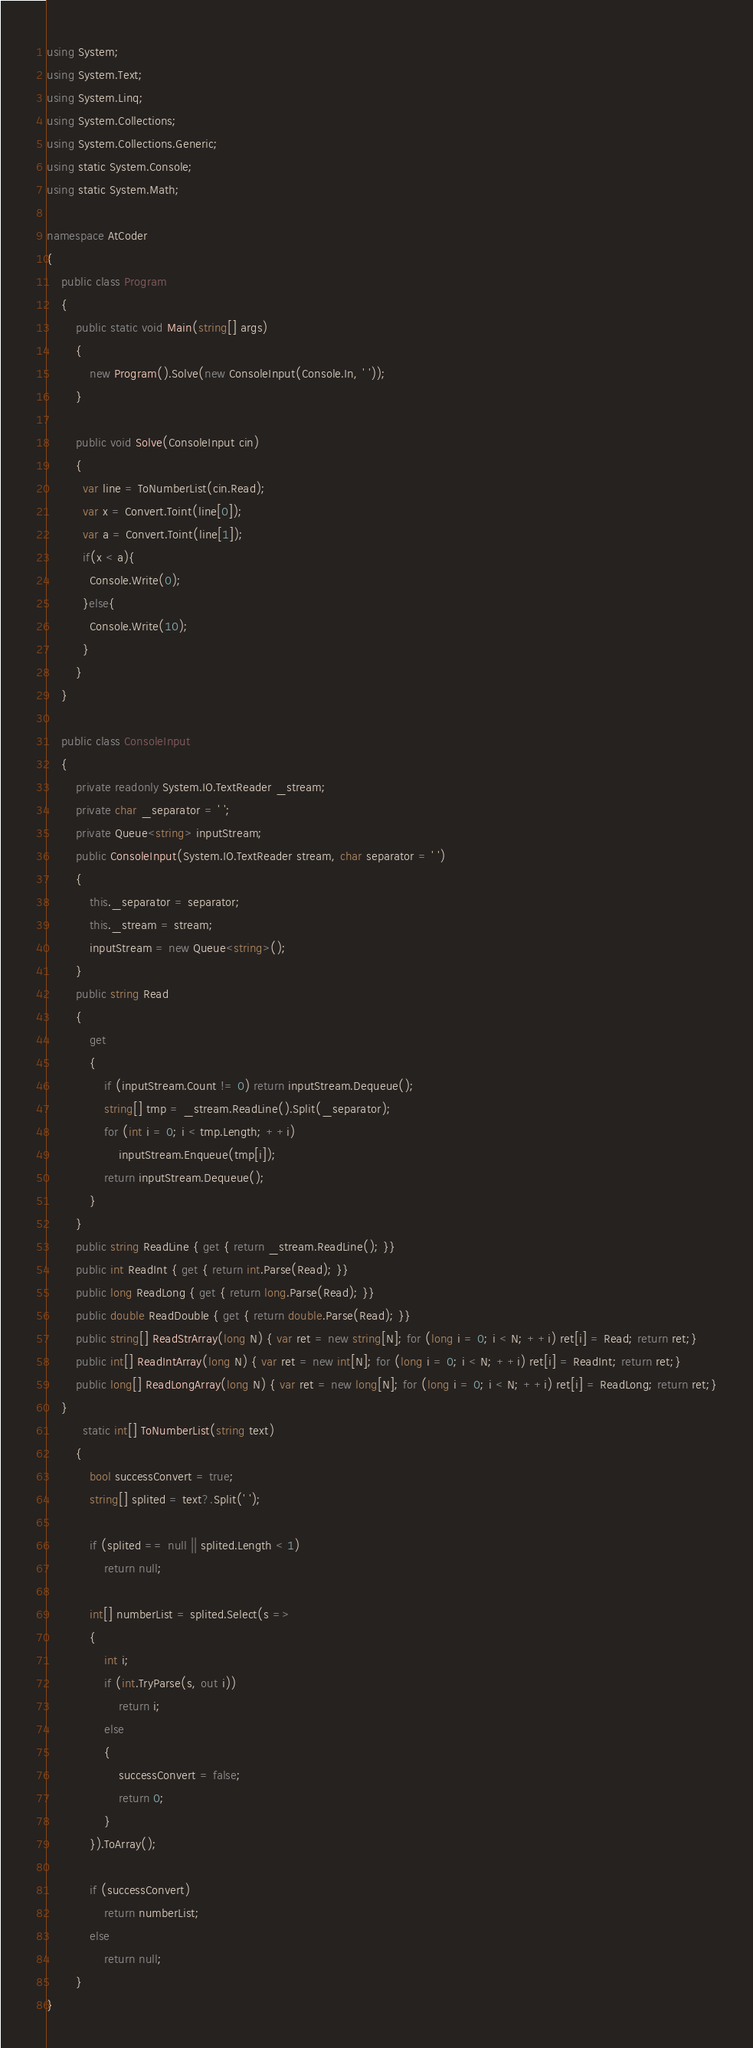<code> <loc_0><loc_0><loc_500><loc_500><_C#_>using System;
using System.Text;
using System.Linq;
using System.Collections;
using System.Collections.Generic;
using static System.Console;
using static System.Math;

namespace AtCoder
{
    public class Program
    {
        public static void Main(string[] args)
        {
            new Program().Solve(new ConsoleInput(Console.In, ' '));
        }

        public void Solve(ConsoleInput cin)
        {
          var line = ToNumberList(cin.Read);
          var x = Convert.Toint(line[0]);
          var a = Convert.Toint(line[1]);
          if(x < a){
            Console.Write(0);
          }else{
            Console.Write(10);
          }
        }
    }

    public class ConsoleInput
    {
        private readonly System.IO.TextReader _stream;
        private char _separator = ' ';
        private Queue<string> inputStream;
        public ConsoleInput(System.IO.TextReader stream, char separator = ' ')
        {
            this._separator = separator;
            this._stream = stream;
            inputStream = new Queue<string>();
        }
        public string Read
        {
            get
            {
                if (inputStream.Count != 0) return inputStream.Dequeue();
                string[] tmp = _stream.ReadLine().Split(_separator);
                for (int i = 0; i < tmp.Length; ++i)
                    inputStream.Enqueue(tmp[i]);
                return inputStream.Dequeue();
            }
        }
        public string ReadLine { get { return _stream.ReadLine(); }}
        public int ReadInt { get { return int.Parse(Read); }}
        public long ReadLong { get { return long.Parse(Read); }}
        public double ReadDouble { get { return double.Parse(Read); }}
        public string[] ReadStrArray(long N) { var ret = new string[N]; for (long i = 0; i < N; ++i) ret[i] = Read; return ret;}
        public int[] ReadIntArray(long N) { var ret = new int[N]; for (long i = 0; i < N; ++i) ret[i] = ReadInt; return ret;}
        public long[] ReadLongArray(long N) { var ret = new long[N]; for (long i = 0; i < N; ++i) ret[i] = ReadLong; return ret;}
    }
          static int[] ToNumberList(string text)
        {
            bool successConvert = true;
            string[] splited = text?.Split(' ');

            if (splited == null || splited.Length < 1)
                return null;

            int[] numberList = splited.Select(s =>
            {
                int i;
                if (int.TryParse(s, out i))
                    return i;
                else
                {
                    successConvert = false;
                    return 0;
                }
            }).ToArray();

            if (successConvert)
                return numberList;
            else
                return null;
        }
}
</code> 